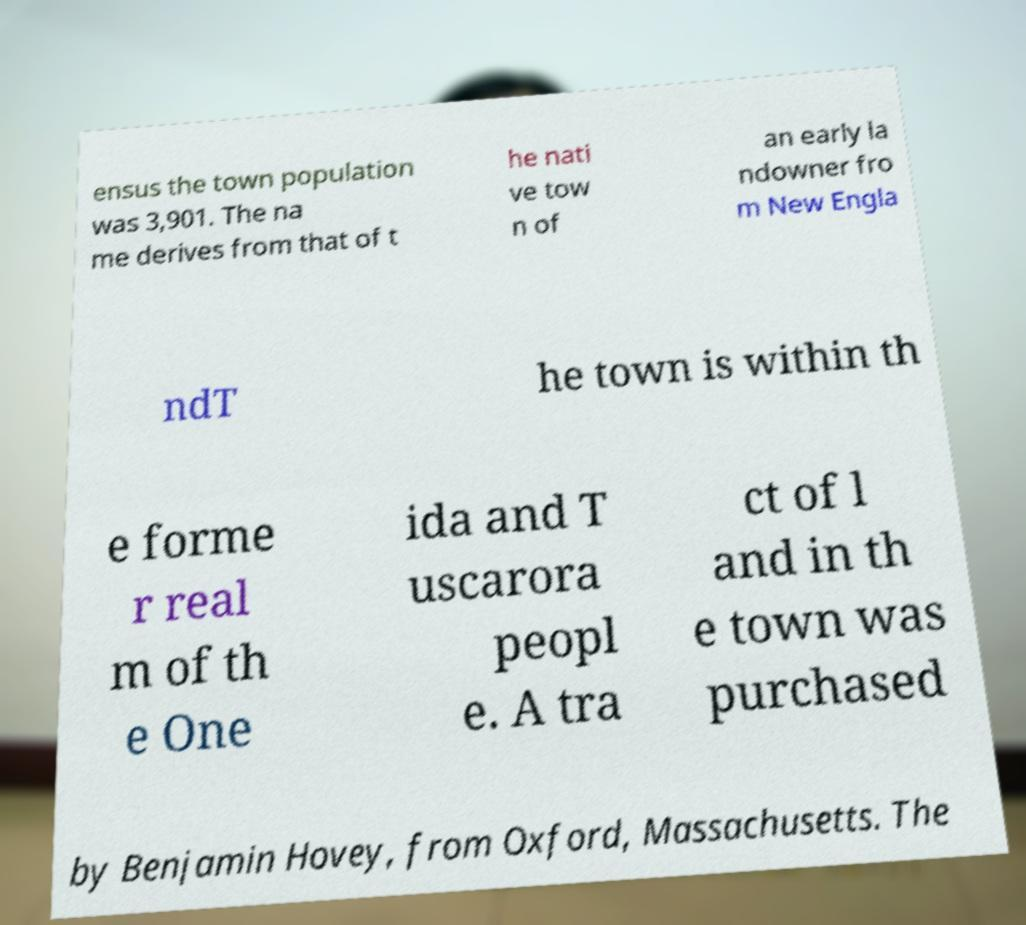Please identify and transcribe the text found in this image. ensus the town population was 3,901. The na me derives from that of t he nati ve tow n of an early la ndowner fro m New Engla ndT he town is within th e forme r real m of th e One ida and T uscarora peopl e. A tra ct of l and in th e town was purchased by Benjamin Hovey, from Oxford, Massachusetts. The 